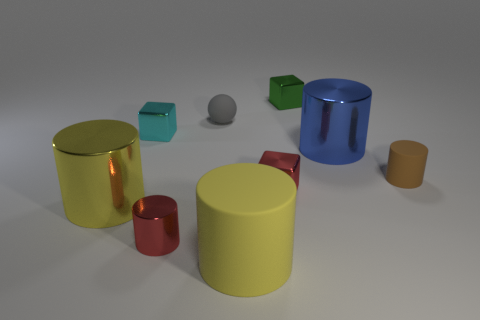Subtract all big matte cylinders. How many cylinders are left? 4 Subtract all brown cylinders. How many cylinders are left? 4 Subtract all green cylinders. Subtract all yellow spheres. How many cylinders are left? 5 Subtract all spheres. How many objects are left? 8 Subtract 1 green blocks. How many objects are left? 8 Subtract all matte objects. Subtract all big brown rubber blocks. How many objects are left? 6 Add 4 red shiny objects. How many red shiny objects are left? 6 Add 8 cyan shiny blocks. How many cyan shiny blocks exist? 9 